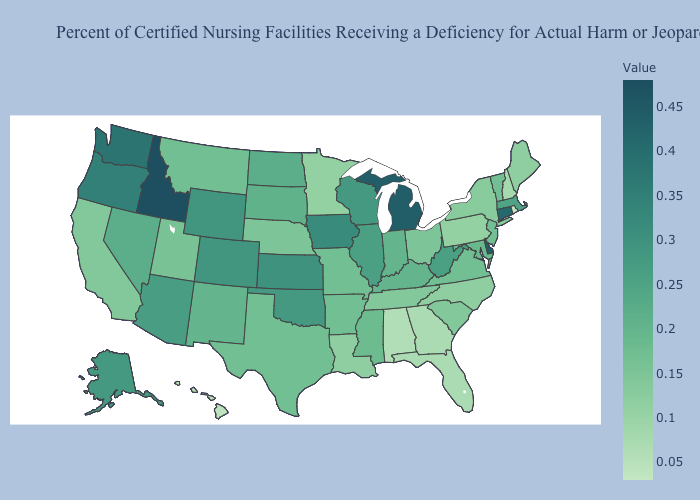Does New York have a lower value than Mississippi?
Be succinct. Yes. Does Washington have the highest value in the USA?
Quick response, please. No. Does Indiana have a higher value than Washington?
Be succinct. No. Does Ohio have a lower value than Alaska?
Keep it brief. Yes. Which states have the lowest value in the South?
Answer briefly. Alabama. 